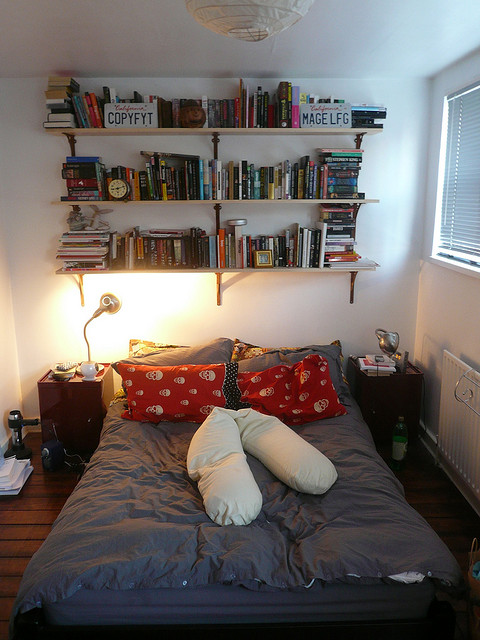What specific books can you spot on the shelf? Do any of them seem particularly interesting? On the shelves, there are numerous books, each with its own unique appeal. Notable titles include popular classics, gripping mysteries, and thought-provoking non-fiction works. For instance, 'Copyfyt' and 'Mage LFG' draw the eye due to their prominent placement. Depending on one's interests, there could be some compelling fantasy novels and intriguing memoirs hidden among the collection, suggesting a well-rounded and exciting library to explore. Based on the arrangement, how might the owner have organized their books? Alphabetically, by genre, or another method? It appears the owner may have organized their books thematically. The top shelf, marked by more whimsical and uniquely titled books such as 'Copyfyt' and 'Mage LFG,' might represent a collection of fantasy or science fiction. The middle shelf, with its colorful variety, could house a mix of genres or personal favorites. The bottom shelf, which appears slightly disheveled, may be reserved for ongoing reads or reference materials. This method of organization highlights functionality and personal preference over strict order. 